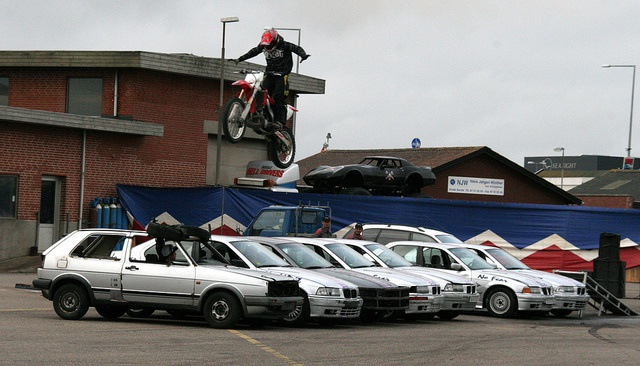Describe the objects in this image and their specific colors. I can see car in lightgray, black, white, gray, and darkgray tones, car in lightgray, black, gray, and darkgray tones, motorcycle in lightgray, black, gray, maroon, and darkgray tones, car in lightgray, black, gray, and darkgray tones, and car in lightgray, black, darkgray, and gray tones in this image. 